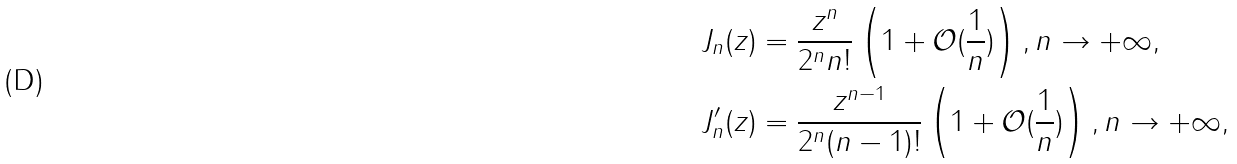<formula> <loc_0><loc_0><loc_500><loc_500>J _ { n } ( z ) & = \frac { z ^ { n } } { 2 ^ { n } n ! } \left ( 1 + \mathcal { O } ( \frac { 1 } { n } ) \right ) , n \rightarrow + \infty , \\ J _ { n } ^ { \prime } ( z ) & = \frac { z ^ { n - 1 } } { 2 ^ { n } ( n - 1 ) ! } \left ( 1 + \mathcal { O } ( \frac { 1 } { n } ) \right ) , n \rightarrow + \infty ,</formula> 